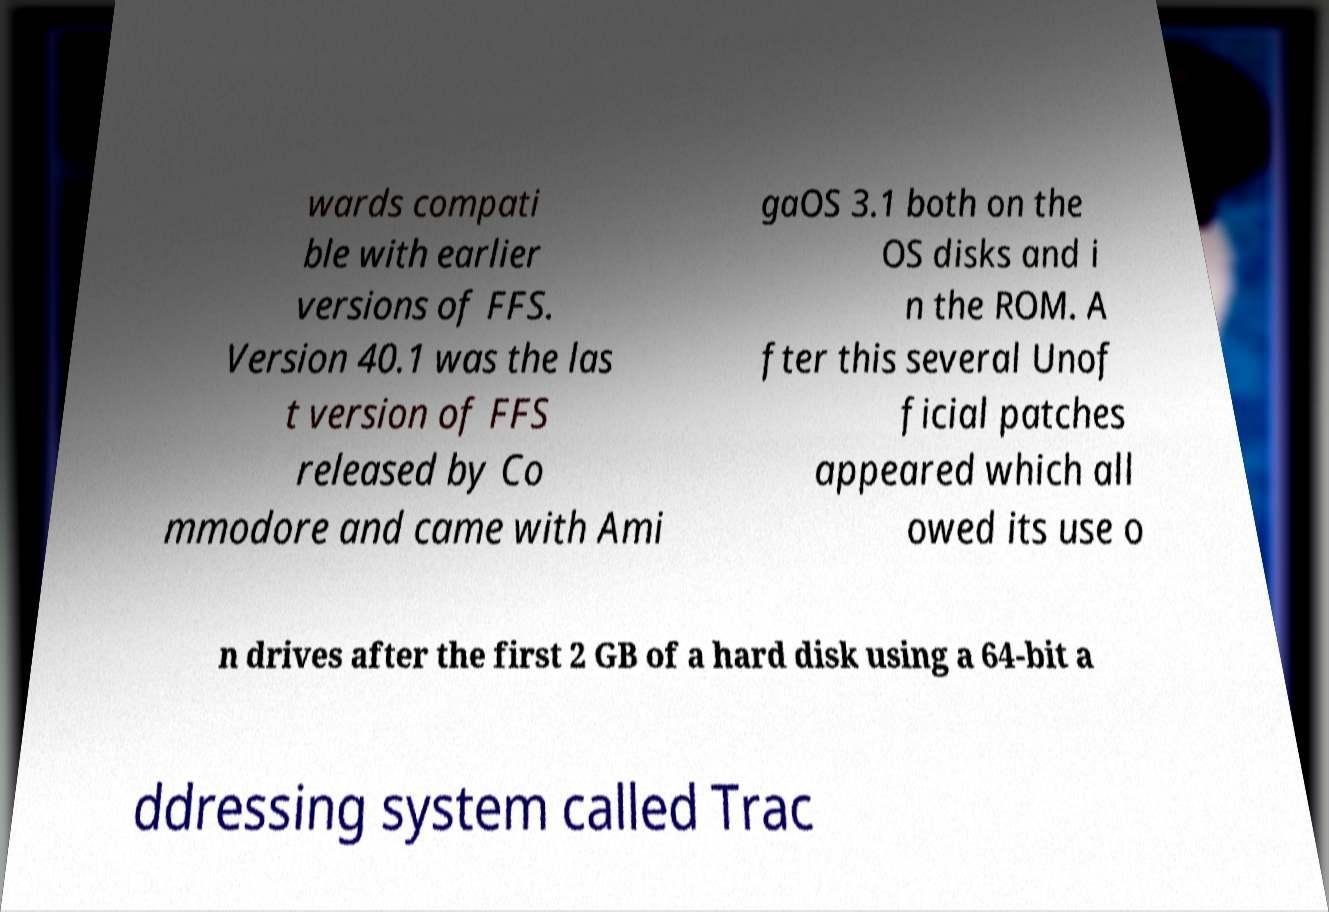There's text embedded in this image that I need extracted. Can you transcribe it verbatim? wards compati ble with earlier versions of FFS. Version 40.1 was the las t version of FFS released by Co mmodore and came with Ami gaOS 3.1 both on the OS disks and i n the ROM. A fter this several Unof ficial patches appeared which all owed its use o n drives after the first 2 GB of a hard disk using a 64-bit a ddressing system called Trac 